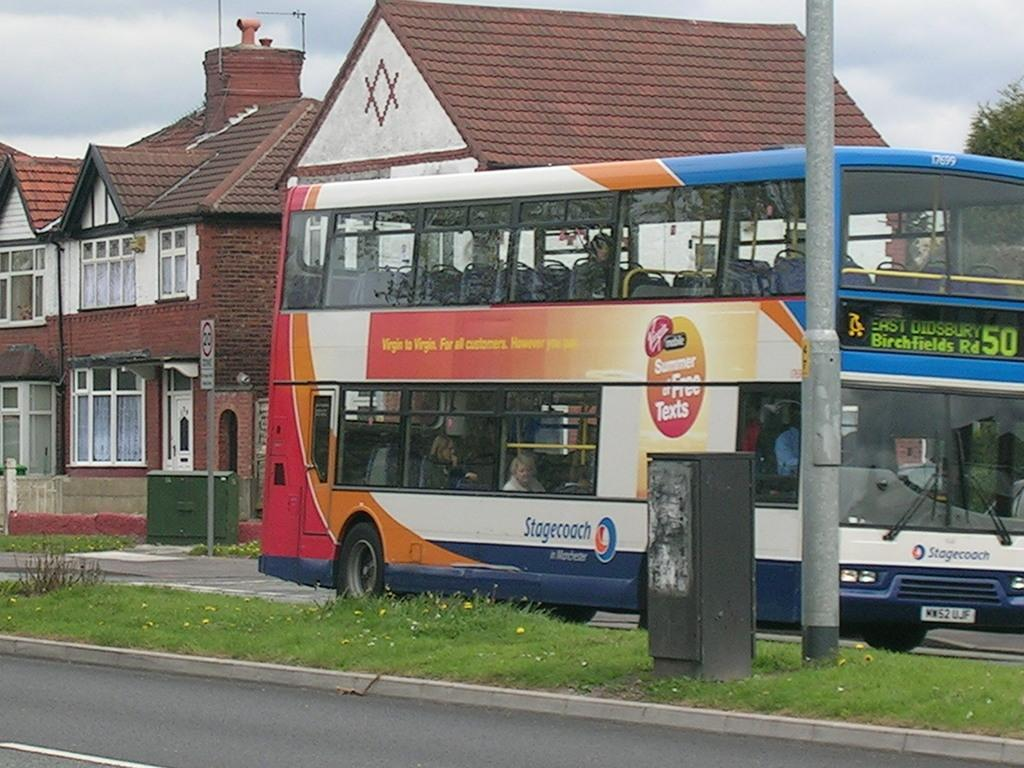<image>
Present a compact description of the photo's key features. A double decker bus which is operated by Stagecoach 